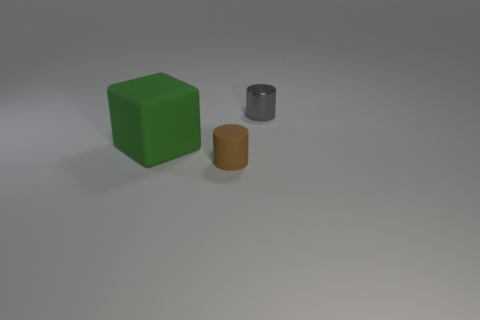Add 2 large green things. How many objects exist? 5 Subtract all blocks. How many objects are left? 2 Subtract all small purple cylinders. Subtract all tiny matte things. How many objects are left? 2 Add 1 metallic things. How many metallic things are left? 2 Add 3 tiny purple cylinders. How many tiny purple cylinders exist? 3 Subtract 0 cyan blocks. How many objects are left? 3 